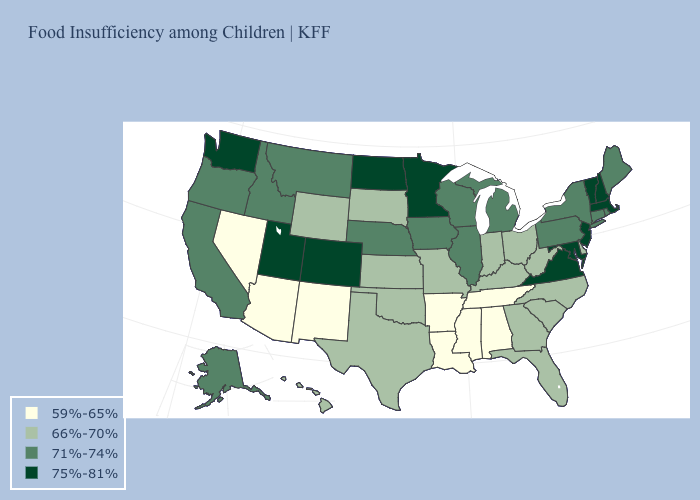What is the value of Maine?
Be succinct. 71%-74%. Among the states that border Nevada , does Utah have the highest value?
Give a very brief answer. Yes. Does New Mexico have the lowest value in the West?
Concise answer only. Yes. Name the states that have a value in the range 66%-70%?
Answer briefly. Delaware, Florida, Georgia, Hawaii, Indiana, Kansas, Kentucky, Missouri, North Carolina, Ohio, Oklahoma, South Carolina, South Dakota, Texas, West Virginia, Wyoming. What is the value of Mississippi?
Concise answer only. 59%-65%. Does Massachusetts have a lower value than West Virginia?
Write a very short answer. No. What is the highest value in the USA?
Answer briefly. 75%-81%. Name the states that have a value in the range 66%-70%?
Be succinct. Delaware, Florida, Georgia, Hawaii, Indiana, Kansas, Kentucky, Missouri, North Carolina, Ohio, Oklahoma, South Carolina, South Dakota, Texas, West Virginia, Wyoming. Name the states that have a value in the range 59%-65%?
Be succinct. Alabama, Arizona, Arkansas, Louisiana, Mississippi, Nevada, New Mexico, Tennessee. What is the value of Alabama?
Keep it brief. 59%-65%. Does Oregon have the same value as Hawaii?
Write a very short answer. No. Name the states that have a value in the range 66%-70%?
Give a very brief answer. Delaware, Florida, Georgia, Hawaii, Indiana, Kansas, Kentucky, Missouri, North Carolina, Ohio, Oklahoma, South Carolina, South Dakota, Texas, West Virginia, Wyoming. What is the value of Washington?
Give a very brief answer. 75%-81%. Does the first symbol in the legend represent the smallest category?
Concise answer only. Yes. 